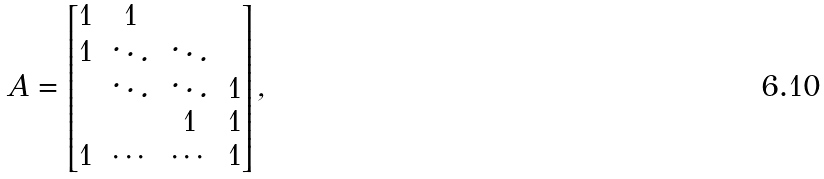Convert formula to latex. <formula><loc_0><loc_0><loc_500><loc_500>A = \begin{bmatrix} 1 & 1 & & \\ 1 & \ddots & \ddots & \\ & \ddots & \ddots & 1 \\ & & 1 & 1 \\ 1 & \cdots & \cdots & 1 \end{bmatrix} ,</formula> 